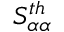Convert formula to latex. <formula><loc_0><loc_0><loc_500><loc_500>S _ { \alpha \alpha } ^ { t h }</formula> 